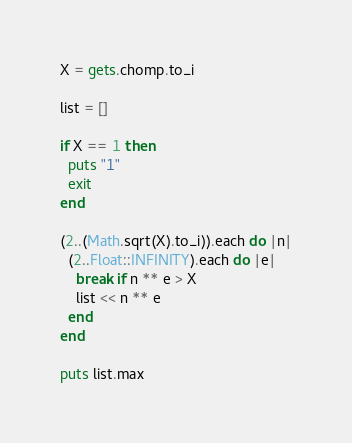Convert code to text. <code><loc_0><loc_0><loc_500><loc_500><_Ruby_>X = gets.chomp.to_i

list = []

if X == 1 then
  puts "1"
  exit
end

(2..(Math.sqrt(X).to_i)).each do |n|
  (2..Float::INFINITY).each do |e|
    break if n ** e > X
    list << n ** e
  end
end

puts list.max</code> 